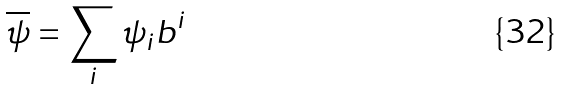Convert formula to latex. <formula><loc_0><loc_0><loc_500><loc_500>\overline { \psi } = \sum _ { i } \psi _ { i } b ^ { i }</formula> 